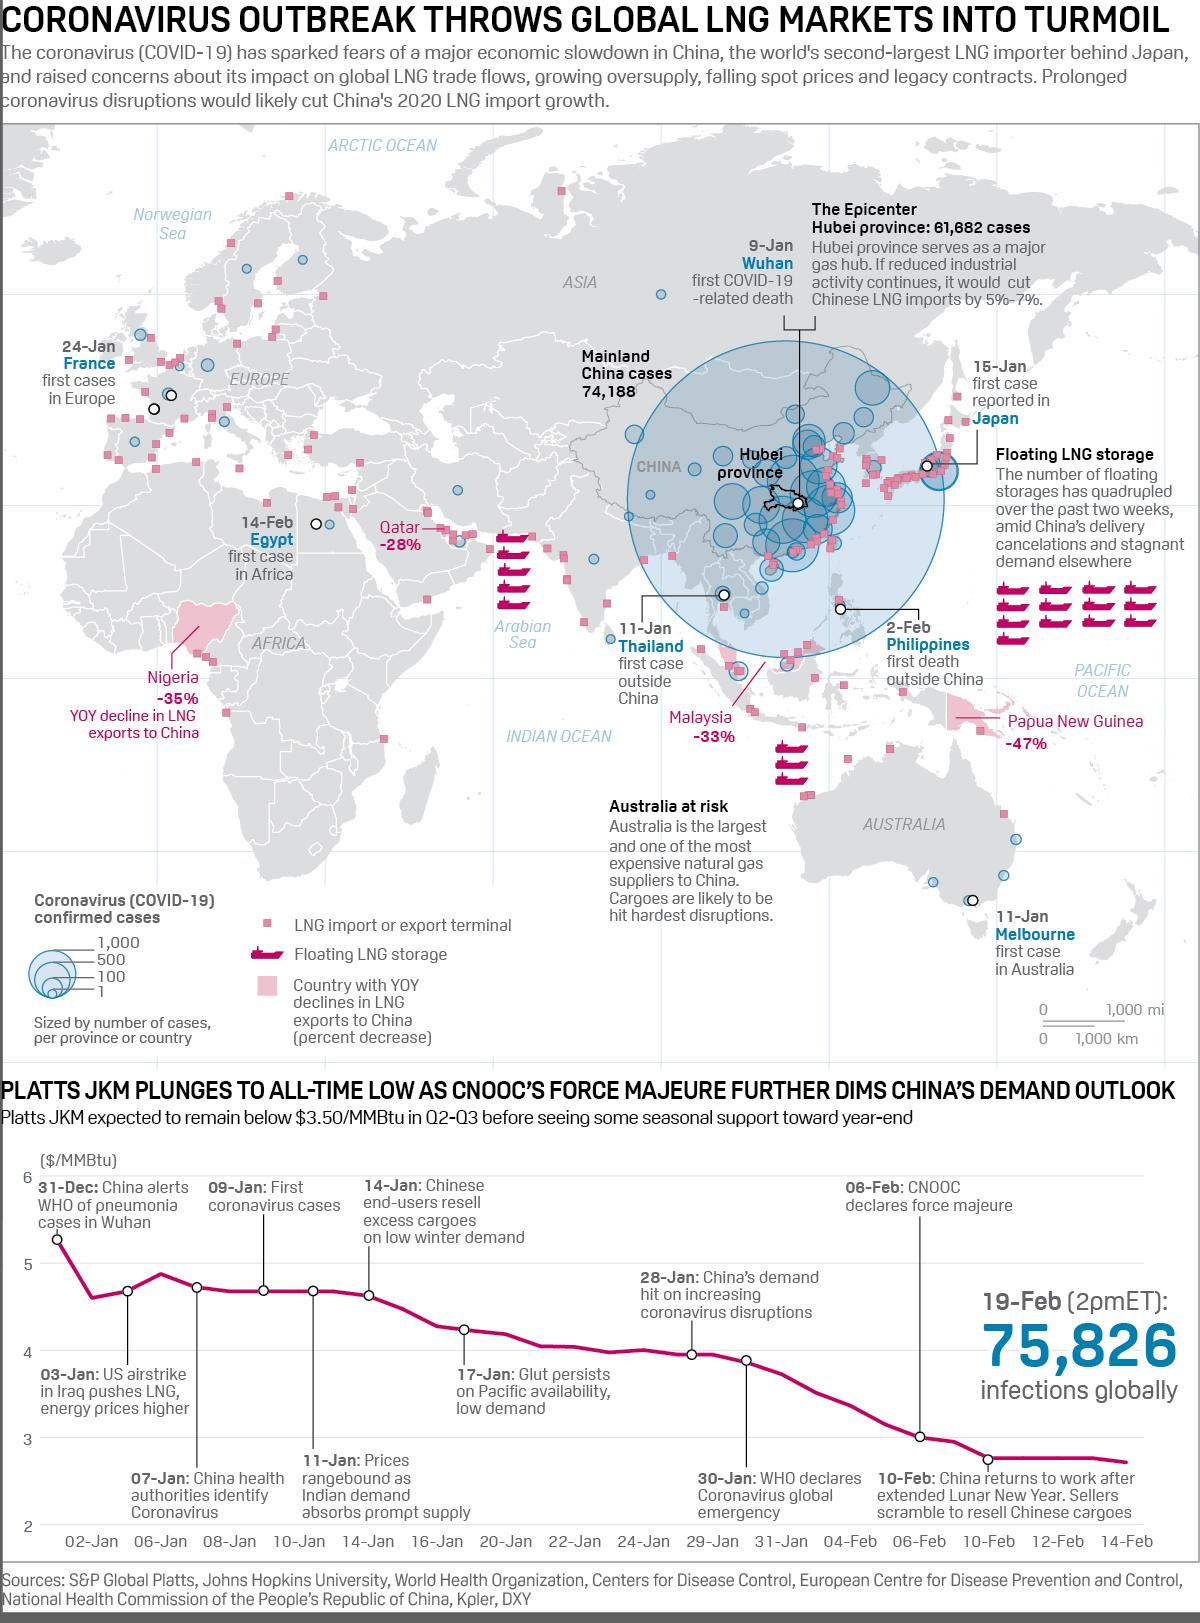List a handful of essential elements in this visual. The Chinese informed the World Health Organization of pneumonia cases in Wuhan on December 31st. The first case of COVID-19 in Australia was reported in Melbourne on 11 January. The first case of the COVID-19 pandemic was reported in Japan on January 15th. On February 8th, CNOOC declared force majeure. Hubei province is an important gas hub of China. 